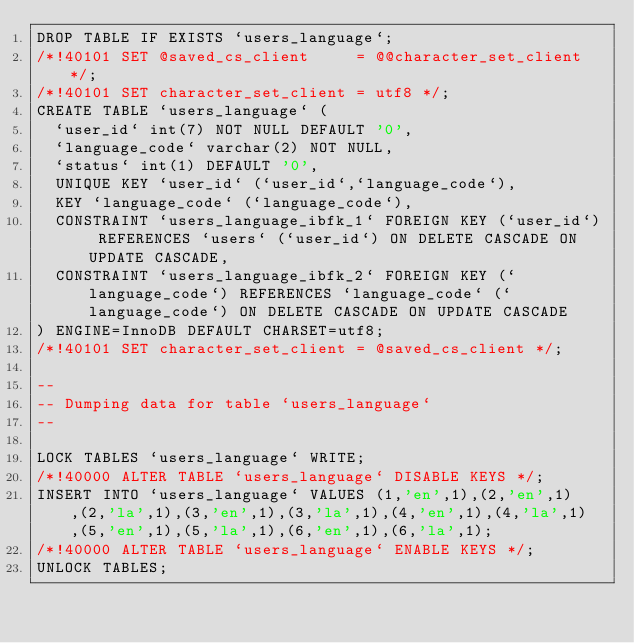<code> <loc_0><loc_0><loc_500><loc_500><_SQL_>DROP TABLE IF EXISTS `users_language`;
/*!40101 SET @saved_cs_client     = @@character_set_client */;
/*!40101 SET character_set_client = utf8 */;
CREATE TABLE `users_language` (
  `user_id` int(7) NOT NULL DEFAULT '0',
  `language_code` varchar(2) NOT NULL,
  `status` int(1) DEFAULT '0',
  UNIQUE KEY `user_id` (`user_id`,`language_code`),
  KEY `language_code` (`language_code`),
  CONSTRAINT `users_language_ibfk_1` FOREIGN KEY (`user_id`) REFERENCES `users` (`user_id`) ON DELETE CASCADE ON UPDATE CASCADE,
  CONSTRAINT `users_language_ibfk_2` FOREIGN KEY (`language_code`) REFERENCES `language_code` (`language_code`) ON DELETE CASCADE ON UPDATE CASCADE
) ENGINE=InnoDB DEFAULT CHARSET=utf8;
/*!40101 SET character_set_client = @saved_cs_client */;

--
-- Dumping data for table `users_language`
--

LOCK TABLES `users_language` WRITE;
/*!40000 ALTER TABLE `users_language` DISABLE KEYS */;
INSERT INTO `users_language` VALUES (1,'en',1),(2,'en',1),(2,'la',1),(3,'en',1),(3,'la',1),(4,'en',1),(4,'la',1),(5,'en',1),(5,'la',1),(6,'en',1),(6,'la',1);
/*!40000 ALTER TABLE `users_language` ENABLE KEYS */;
UNLOCK TABLES;

</code> 